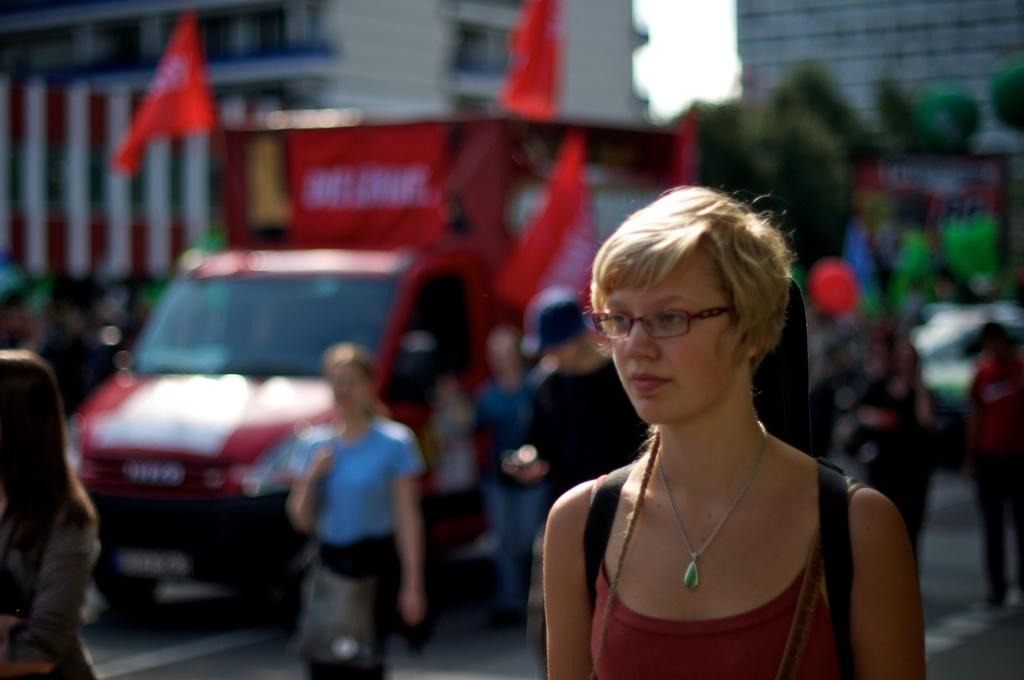Who or what can be seen in the image? There are people in the image. What else is present in the image besides people? There are vehicles, trees, buildings, flags, and the sky is visible in the image. Can you describe the vehicles in the image? The provided facts do not specify the type or characteristics of the vehicles. How many flags are visible in the image? The provided facts do not specify the number of flags present. Are there any spiders crawling on the plastic expert in the image? There is no mention of spiders, plastic, or an expert in the provided facts, so this scenario is not present in the image. 